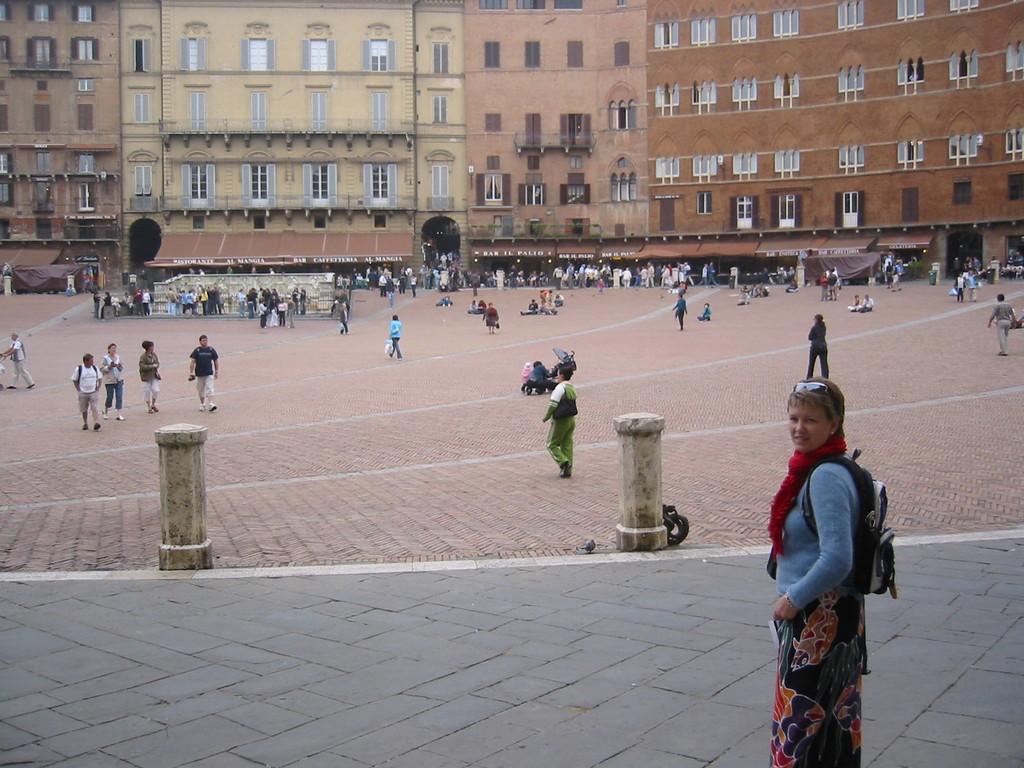Can you describe this image briefly? In this image we can see persons standing on the floor. In the background we can see buildings, windows and iron grills. 